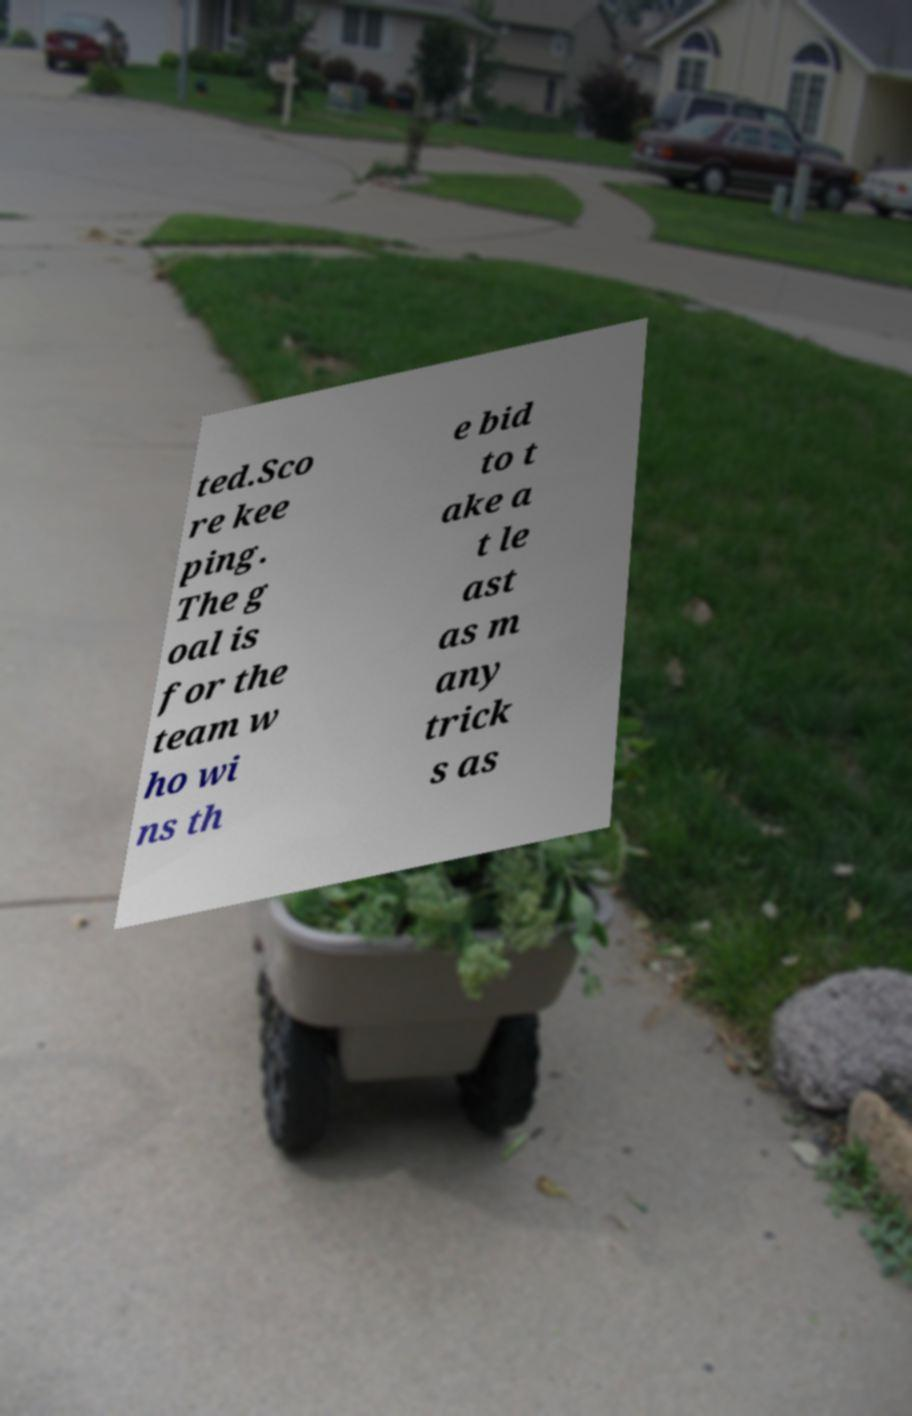Can you accurately transcribe the text from the provided image for me? ted.Sco re kee ping. The g oal is for the team w ho wi ns th e bid to t ake a t le ast as m any trick s as 